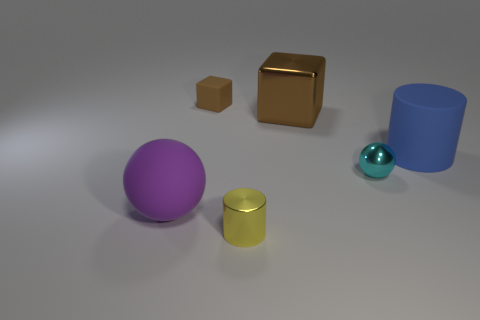Does the purple thing that is in front of the metallic block have the same material as the sphere behind the purple thing?
Provide a short and direct response. No. There is a large thing that is the same color as the small matte block; what is its shape?
Your answer should be compact. Cube. How many objects are either things that are in front of the blue rubber object or tiny objects behind the blue rubber thing?
Make the answer very short. 4. There is a large rubber object that is in front of the blue cylinder; is it the same color as the thing right of the small metallic sphere?
Provide a short and direct response. No. What is the shape of the small thing that is both behind the tiny yellow thing and right of the small matte thing?
Provide a succinct answer. Sphere. What is the color of the ball that is the same size as the brown metallic thing?
Provide a short and direct response. Purple. Are there any large spheres of the same color as the large cube?
Keep it short and to the point. No. There is a cube that is in front of the small brown matte thing; does it have the same size as the cylinder behind the big rubber sphere?
Offer a very short reply. Yes. The big object that is behind the shiny ball and left of the blue object is made of what material?
Keep it short and to the point. Metal. There is a thing that is the same color as the large shiny cube; what is its size?
Keep it short and to the point. Small. 